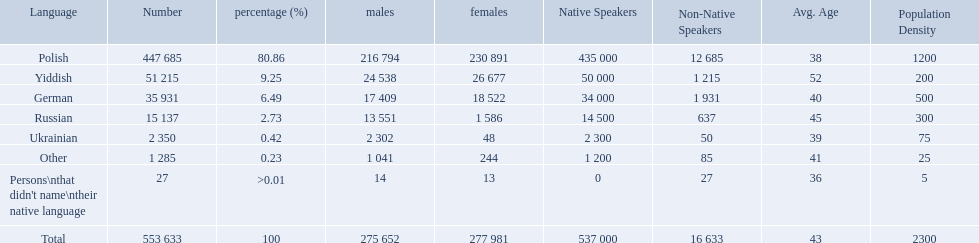What was the least spoken language Ukrainian. What was the most spoken? Polish. What languages are there? Polish, Yiddish, German, Russian, Ukrainian. What numbers speak these languages? 447 685, 51 215, 35 931, 15 137, 2 350. What numbers are not listed as speaking these languages? 1 285, 27. What are the totals of these speakers? 553 633. 